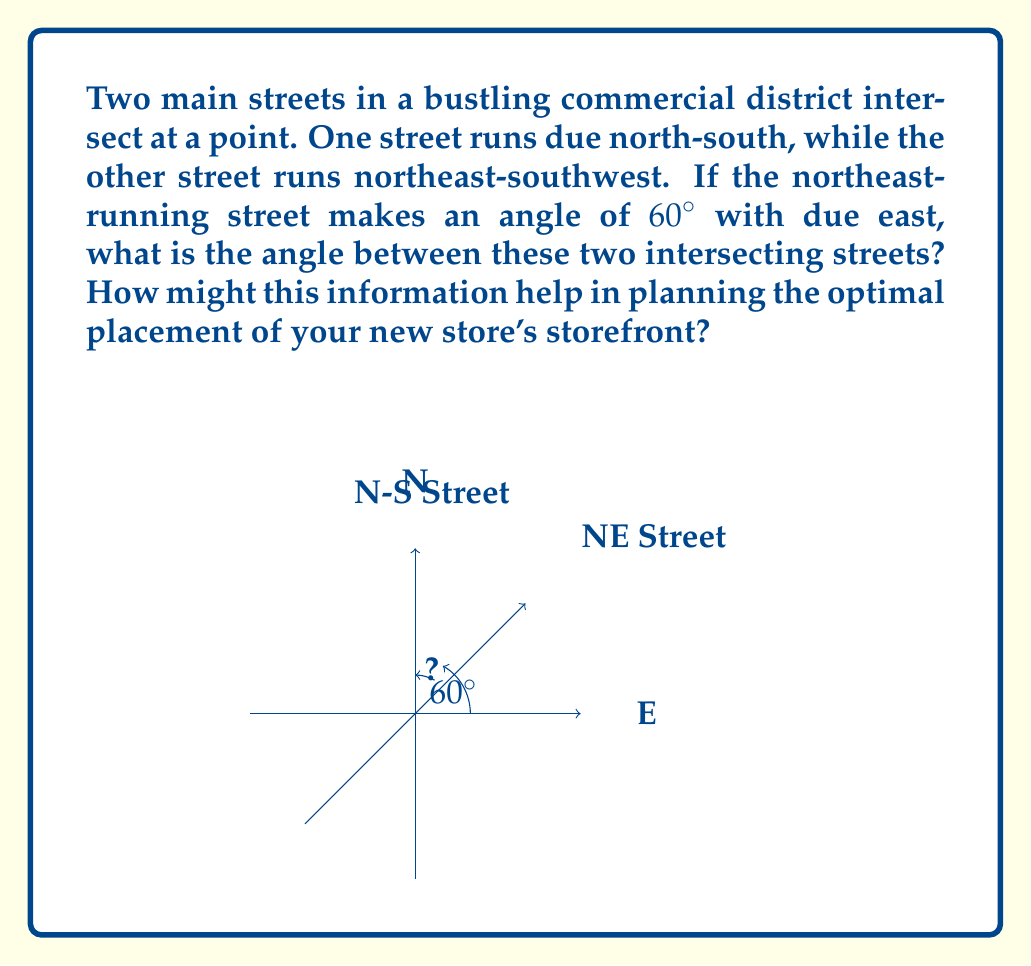Solve this math problem. Let's approach this step-by-step:

1) First, we need to understand the given information:
   - One street runs north-south (N-S)
   - The other street runs northeast-southwest (NE-SW)
   - The NE-SW street makes a $60^\circ$ angle with due east

2) In a coordinate system where east is $0^\circ$ and angles increase counterclockwise:
   - The N-S street is at $90^\circ$
   - The NE-SW street is at $60^\circ$

3) To find the angle between these streets, we subtract the smaller angle from the larger:

   $$ 90^\circ - 60^\circ = 30^\circ $$

4) Therefore, the angle between the two streets is $30^\circ$.

5) For optimal storefront placement:
   - A $30^\circ$ angle creates a sharp corner, which could be advantageous for visibility.
   - A store placed at this intersection would have exposure to traffic from both streets.
   - The acute angle might allow for an interesting architectural design that stands out.
   - However, the sharp angle might also limit the available frontage space, so careful planning would be needed to maximize the storefront's potential.
Answer: $30^\circ$ 